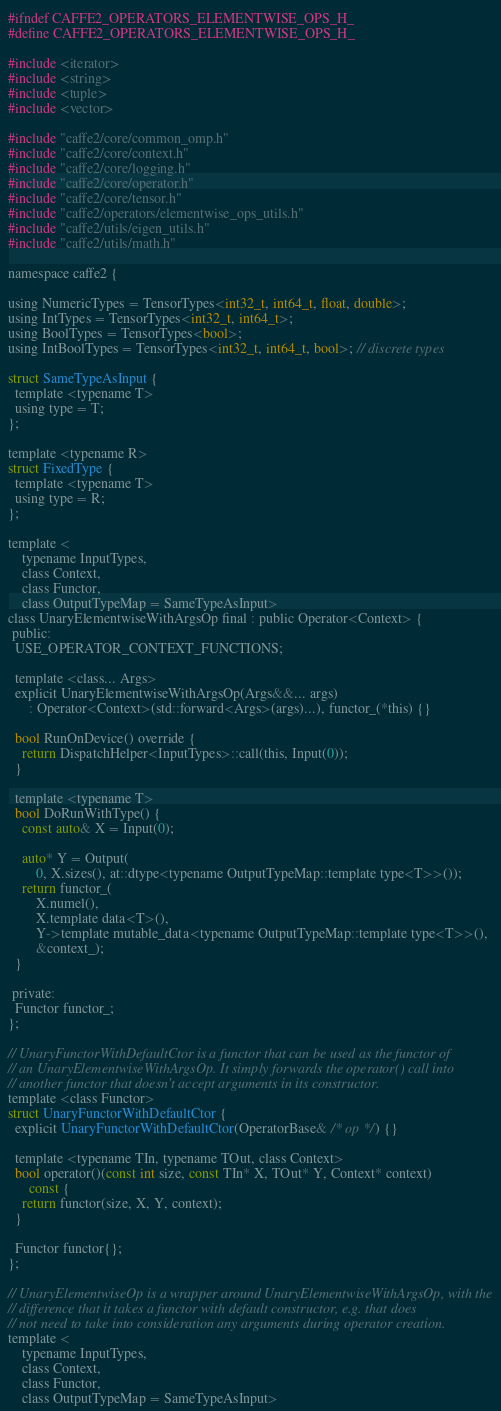<code> <loc_0><loc_0><loc_500><loc_500><_C_>#ifndef CAFFE2_OPERATORS_ELEMENTWISE_OPS_H_
#define CAFFE2_OPERATORS_ELEMENTWISE_OPS_H_

#include <iterator>
#include <string>
#include <tuple>
#include <vector>

#include "caffe2/core/common_omp.h"
#include "caffe2/core/context.h"
#include "caffe2/core/logging.h"
#include "caffe2/core/operator.h"
#include "caffe2/core/tensor.h"
#include "caffe2/operators/elementwise_ops_utils.h"
#include "caffe2/utils/eigen_utils.h"
#include "caffe2/utils/math.h"

namespace caffe2 {

using NumericTypes = TensorTypes<int32_t, int64_t, float, double>;
using IntTypes = TensorTypes<int32_t, int64_t>;
using BoolTypes = TensorTypes<bool>;
using IntBoolTypes = TensorTypes<int32_t, int64_t, bool>; // discrete types

struct SameTypeAsInput {
  template <typename T>
  using type = T;
};

template <typename R>
struct FixedType {
  template <typename T>
  using type = R;
};

template <
    typename InputTypes,
    class Context,
    class Functor,
    class OutputTypeMap = SameTypeAsInput>
class UnaryElementwiseWithArgsOp final : public Operator<Context> {
 public:
  USE_OPERATOR_CONTEXT_FUNCTIONS;

  template <class... Args>
  explicit UnaryElementwiseWithArgsOp(Args&&... args)
      : Operator<Context>(std::forward<Args>(args)...), functor_(*this) {}

  bool RunOnDevice() override {
    return DispatchHelper<InputTypes>::call(this, Input(0));
  }

  template <typename T>
  bool DoRunWithType() {
    const auto& X = Input(0);

    auto* Y = Output(
        0, X.sizes(), at::dtype<typename OutputTypeMap::template type<T>>());
    return functor_(
        X.numel(),
        X.template data<T>(),
        Y->template mutable_data<typename OutputTypeMap::template type<T>>(),
        &context_);
  }

 private:
  Functor functor_;
};

// UnaryFunctorWithDefaultCtor is a functor that can be used as the functor of
// an UnaryElementwiseWithArgsOp. It simply forwards the operator() call into
// another functor that doesn't accept arguments in its constructor.
template <class Functor>
struct UnaryFunctorWithDefaultCtor {
  explicit UnaryFunctorWithDefaultCtor(OperatorBase& /* op */) {}

  template <typename TIn, typename TOut, class Context>
  bool operator()(const int size, const TIn* X, TOut* Y, Context* context)
      const {
    return functor(size, X, Y, context);
  }

  Functor functor{};
};

// UnaryElementwiseOp is a wrapper around UnaryElementwiseWithArgsOp, with the
// difference that it takes a functor with default constructor, e.g. that does
// not need to take into consideration any arguments during operator creation.
template <
    typename InputTypes,
    class Context,
    class Functor,
    class OutputTypeMap = SameTypeAsInput></code> 